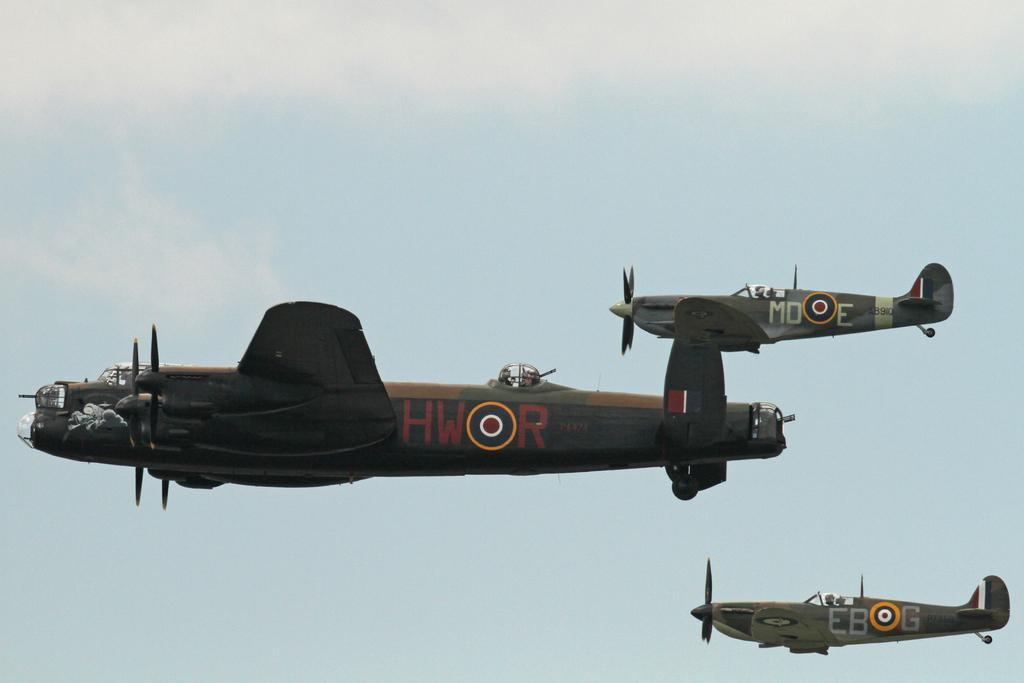What is the main subject of the image? The main subject of the image is airplanes. What are the airplanes doing in the image? The airplanes are flying in the sky. Are there any dinosaurs visible in the image? No, there are no dinosaurs present in the image. Is there any quicksand visible in the image? No, there is no quicksand present in the image. 